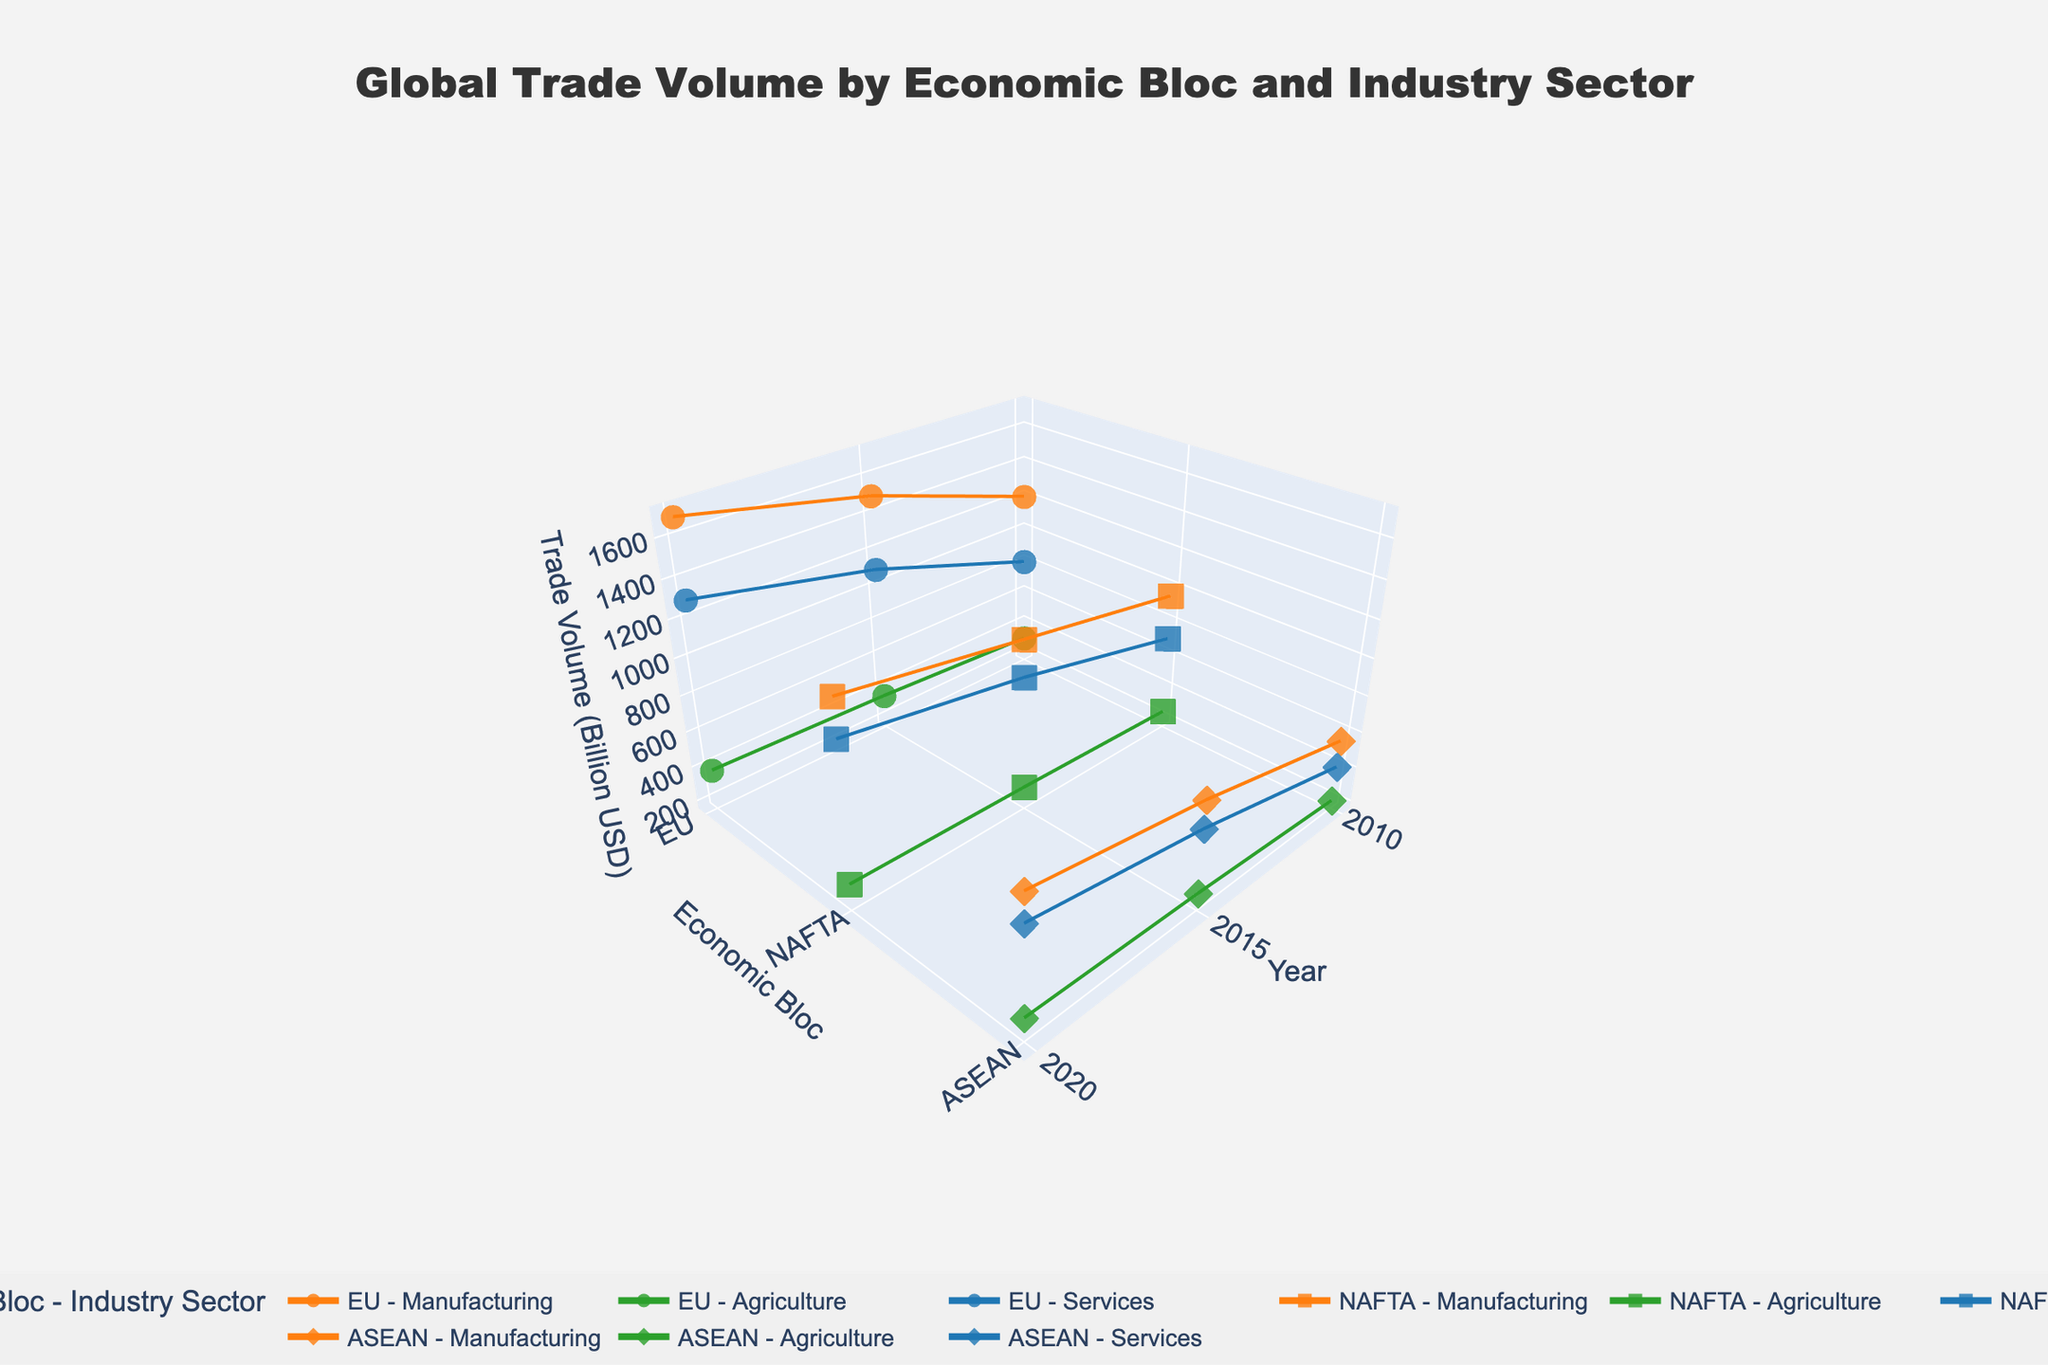What's the title of the figure? The title is located at the top center of the figure. It reads "Global Trade Volume by Economic Bloc and Industry Sector" in a large, bold font.
Answer: Global Trade Volume by Economic Bloc and Industry Sector Which industry sector had the highest trade volume in 2020 for NAFTA? Locate the points for the year 2020 in the NAFTA bloc. Compare the positions of the symbols for Manufacturing, Agriculture, and Services on the z-axis.
Answer: Manufacturing How did the trade volume in the Services sector for the EU change from 2010 to 2020? Find the points corresponding to the Services sector for the EU in 2010 and 2020. Observe the change in their z-axis values. Calculate the difference between the trade volumes in these years. The trade volume in 2010 was 800 billion USD, and in 2020, it was 1300 billion USD.
Answer: Increased by 500 billion USD Which economic bloc showed the most consistent growth in the Manufacturing sector from 2010 to 2020? Examine the lines connecting the points for the Manufacturing sector for each economic bloc across the years 2010, 2015, and 2020. Determine which line has the most steady upward trend.
Answer: EU What is the sum of Trade Volumes for Agriculture across all economic blocs in 2020? Identify and sum the z-axis values for the Agriculture sector points for EU, NAFTA, and ASEAN in 2020. The values are 380, 300, and 280 billion USD, respectively.
Answer: 960 billion USD In which year did the ASEAN bloc experience the highest trade volume in the Services sector? Locate the points for the ASEAN bloc in the Services sector and compare their z-axis values for the years 2010, 2015, and 2020.
Answer: 2020 How does the trade volume of the EU in Manufacturing in 2015 compare to the NAFTA bloc in the same sector and year? Compare the z-axis values of the points for Manufacturing in 2015 for the EU and NAFTA bloc. EU has a trade volume of 1500 billion USD, while NAFTA has 1100 billion USD.
Answer: EU is higher by 400 billion USD What's the average trade volume in the Agriculture sector for the ASEAN bloc from 2010 to 2020? Find the trade volumes for the Agriculture sector in the ASEAN bloc for 2010, 2015, and 2020. Sum these values and divide by the number of years. The values are 200, 250, and 280 billion USD. (200+250+280)/3 = 243.33 billion USD
Answer: 243.33 billion USD What is the difference in trade volume in Manufacturing between the highest and lowest economic blocs in 2020? Locate the trade volume of Manufacturing for all blocs in 2020. The highest is the EU with 1700 billion USD, and the lowest is ASEAN with 900 billion USD. Calculate the difference between these values.
Answer: 800 billion USD 